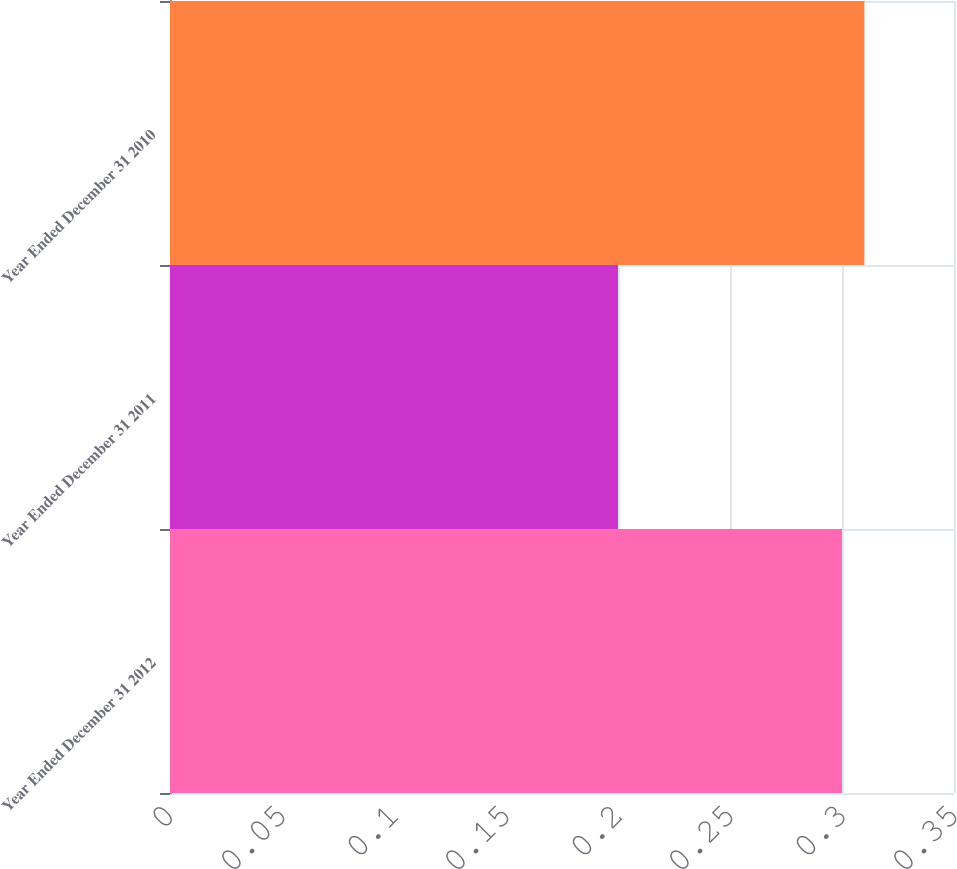<chart> <loc_0><loc_0><loc_500><loc_500><bar_chart><fcel>Year Ended December 31 2012<fcel>Year Ended December 31 2011<fcel>Year Ended December 31 2010<nl><fcel>0.3<fcel>0.2<fcel>0.31<nl></chart> 